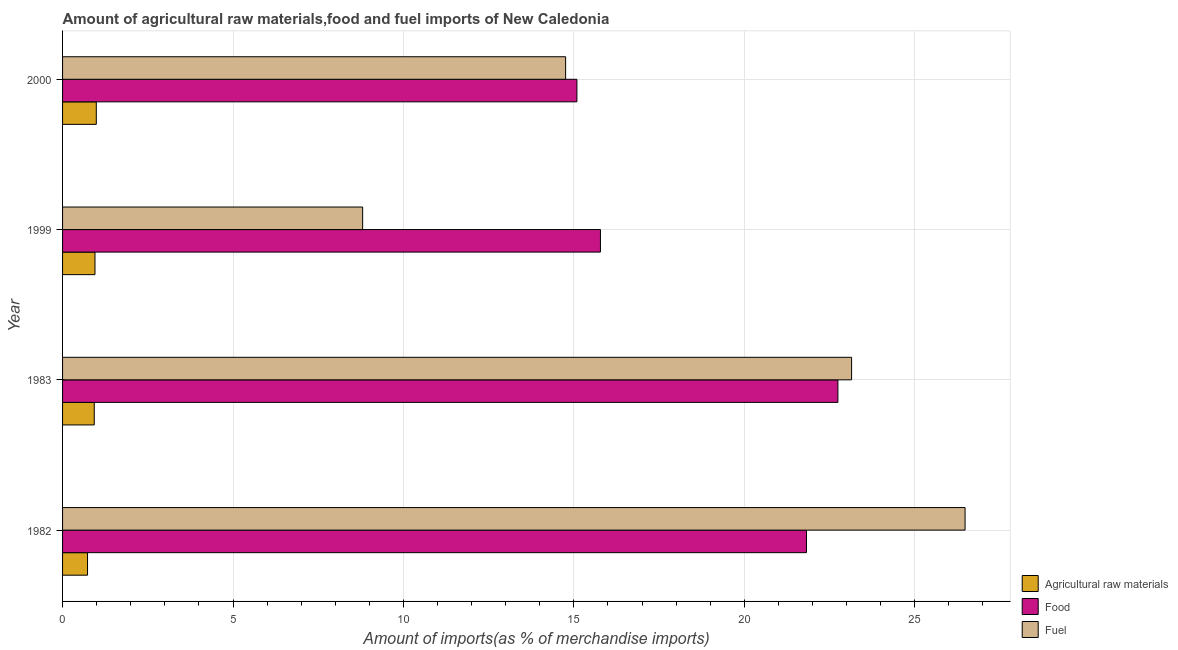How many bars are there on the 1st tick from the bottom?
Keep it short and to the point. 3. What is the label of the 2nd group of bars from the top?
Give a very brief answer. 1999. In how many cases, is the number of bars for a given year not equal to the number of legend labels?
Your answer should be very brief. 0. What is the percentage of food imports in 1983?
Your answer should be compact. 22.75. Across all years, what is the maximum percentage of fuel imports?
Your answer should be very brief. 26.48. Across all years, what is the minimum percentage of fuel imports?
Provide a short and direct response. 8.8. In which year was the percentage of raw materials imports maximum?
Offer a terse response. 2000. In which year was the percentage of fuel imports minimum?
Ensure brevity in your answer.  1999. What is the total percentage of fuel imports in the graph?
Give a very brief answer. 73.19. What is the difference between the percentage of raw materials imports in 1983 and that in 2000?
Provide a succinct answer. -0.06. What is the difference between the percentage of food imports in 1983 and the percentage of raw materials imports in 2000?
Your response must be concise. 21.76. What is the average percentage of raw materials imports per year?
Provide a succinct answer. 0.9. In the year 1999, what is the difference between the percentage of food imports and percentage of fuel imports?
Make the answer very short. 6.98. In how many years, is the percentage of raw materials imports greater than 6 %?
Give a very brief answer. 0. What is the ratio of the percentage of raw materials imports in 1983 to that in 2000?
Offer a very short reply. 0.94. Is the percentage of food imports in 1982 less than that in 1983?
Provide a short and direct response. Yes. What is the difference between the highest and the second highest percentage of raw materials imports?
Your response must be concise. 0.04. What is the difference between the highest and the lowest percentage of raw materials imports?
Your answer should be compact. 0.26. In how many years, is the percentage of food imports greater than the average percentage of food imports taken over all years?
Provide a succinct answer. 2. Is the sum of the percentage of fuel imports in 1982 and 1999 greater than the maximum percentage of raw materials imports across all years?
Give a very brief answer. Yes. What does the 2nd bar from the top in 2000 represents?
Ensure brevity in your answer.  Food. What does the 1st bar from the bottom in 2000 represents?
Your answer should be very brief. Agricultural raw materials. Is it the case that in every year, the sum of the percentage of raw materials imports and percentage of food imports is greater than the percentage of fuel imports?
Offer a terse response. No. How many bars are there?
Provide a short and direct response. 12. How many years are there in the graph?
Offer a terse response. 4. What is the difference between two consecutive major ticks on the X-axis?
Your response must be concise. 5. Are the values on the major ticks of X-axis written in scientific E-notation?
Provide a succinct answer. No. What is the title of the graph?
Provide a short and direct response. Amount of agricultural raw materials,food and fuel imports of New Caledonia. What is the label or title of the X-axis?
Make the answer very short. Amount of imports(as % of merchandise imports). What is the label or title of the Y-axis?
Give a very brief answer. Year. What is the Amount of imports(as % of merchandise imports) in Agricultural raw materials in 1982?
Your answer should be very brief. 0.73. What is the Amount of imports(as % of merchandise imports) in Food in 1982?
Your response must be concise. 21.82. What is the Amount of imports(as % of merchandise imports) in Fuel in 1982?
Provide a short and direct response. 26.48. What is the Amount of imports(as % of merchandise imports) of Agricultural raw materials in 1983?
Provide a short and direct response. 0.93. What is the Amount of imports(as % of merchandise imports) in Food in 1983?
Keep it short and to the point. 22.75. What is the Amount of imports(as % of merchandise imports) in Fuel in 1983?
Keep it short and to the point. 23.15. What is the Amount of imports(as % of merchandise imports) of Agricultural raw materials in 1999?
Ensure brevity in your answer.  0.95. What is the Amount of imports(as % of merchandise imports) in Food in 1999?
Ensure brevity in your answer.  15.78. What is the Amount of imports(as % of merchandise imports) in Fuel in 1999?
Your response must be concise. 8.8. What is the Amount of imports(as % of merchandise imports) of Agricultural raw materials in 2000?
Offer a very short reply. 0.99. What is the Amount of imports(as % of merchandise imports) in Food in 2000?
Make the answer very short. 15.09. What is the Amount of imports(as % of merchandise imports) in Fuel in 2000?
Provide a short and direct response. 14.76. Across all years, what is the maximum Amount of imports(as % of merchandise imports) of Agricultural raw materials?
Your answer should be very brief. 0.99. Across all years, what is the maximum Amount of imports(as % of merchandise imports) in Food?
Ensure brevity in your answer.  22.75. Across all years, what is the maximum Amount of imports(as % of merchandise imports) in Fuel?
Make the answer very short. 26.48. Across all years, what is the minimum Amount of imports(as % of merchandise imports) of Agricultural raw materials?
Provide a short and direct response. 0.73. Across all years, what is the minimum Amount of imports(as % of merchandise imports) of Food?
Your response must be concise. 15.09. Across all years, what is the minimum Amount of imports(as % of merchandise imports) of Fuel?
Provide a short and direct response. 8.8. What is the total Amount of imports(as % of merchandise imports) of Agricultural raw materials in the graph?
Provide a short and direct response. 3.6. What is the total Amount of imports(as % of merchandise imports) in Food in the graph?
Ensure brevity in your answer.  75.44. What is the total Amount of imports(as % of merchandise imports) of Fuel in the graph?
Your response must be concise. 73.19. What is the difference between the Amount of imports(as % of merchandise imports) of Agricultural raw materials in 1982 and that in 1983?
Ensure brevity in your answer.  -0.2. What is the difference between the Amount of imports(as % of merchandise imports) in Food in 1982 and that in 1983?
Give a very brief answer. -0.92. What is the difference between the Amount of imports(as % of merchandise imports) in Fuel in 1982 and that in 1983?
Offer a terse response. 3.33. What is the difference between the Amount of imports(as % of merchandise imports) in Agricultural raw materials in 1982 and that in 1999?
Ensure brevity in your answer.  -0.22. What is the difference between the Amount of imports(as % of merchandise imports) of Food in 1982 and that in 1999?
Offer a very short reply. 6.04. What is the difference between the Amount of imports(as % of merchandise imports) of Fuel in 1982 and that in 1999?
Your response must be concise. 17.67. What is the difference between the Amount of imports(as % of merchandise imports) in Agricultural raw materials in 1982 and that in 2000?
Offer a very short reply. -0.26. What is the difference between the Amount of imports(as % of merchandise imports) in Food in 1982 and that in 2000?
Your answer should be compact. 6.73. What is the difference between the Amount of imports(as % of merchandise imports) in Fuel in 1982 and that in 2000?
Give a very brief answer. 11.72. What is the difference between the Amount of imports(as % of merchandise imports) of Agricultural raw materials in 1983 and that in 1999?
Your answer should be very brief. -0.02. What is the difference between the Amount of imports(as % of merchandise imports) of Food in 1983 and that in 1999?
Your answer should be very brief. 6.97. What is the difference between the Amount of imports(as % of merchandise imports) in Fuel in 1983 and that in 1999?
Give a very brief answer. 14.34. What is the difference between the Amount of imports(as % of merchandise imports) of Agricultural raw materials in 1983 and that in 2000?
Ensure brevity in your answer.  -0.06. What is the difference between the Amount of imports(as % of merchandise imports) in Food in 1983 and that in 2000?
Give a very brief answer. 7.66. What is the difference between the Amount of imports(as % of merchandise imports) in Fuel in 1983 and that in 2000?
Ensure brevity in your answer.  8.39. What is the difference between the Amount of imports(as % of merchandise imports) of Agricultural raw materials in 1999 and that in 2000?
Make the answer very short. -0.04. What is the difference between the Amount of imports(as % of merchandise imports) of Food in 1999 and that in 2000?
Keep it short and to the point. 0.69. What is the difference between the Amount of imports(as % of merchandise imports) in Fuel in 1999 and that in 2000?
Your answer should be compact. -5.95. What is the difference between the Amount of imports(as % of merchandise imports) in Agricultural raw materials in 1982 and the Amount of imports(as % of merchandise imports) in Food in 1983?
Your answer should be very brief. -22.01. What is the difference between the Amount of imports(as % of merchandise imports) of Agricultural raw materials in 1982 and the Amount of imports(as % of merchandise imports) of Fuel in 1983?
Offer a terse response. -22.42. What is the difference between the Amount of imports(as % of merchandise imports) of Food in 1982 and the Amount of imports(as % of merchandise imports) of Fuel in 1983?
Your response must be concise. -1.32. What is the difference between the Amount of imports(as % of merchandise imports) in Agricultural raw materials in 1982 and the Amount of imports(as % of merchandise imports) in Food in 1999?
Your response must be concise. -15.05. What is the difference between the Amount of imports(as % of merchandise imports) in Agricultural raw materials in 1982 and the Amount of imports(as % of merchandise imports) in Fuel in 1999?
Make the answer very short. -8.07. What is the difference between the Amount of imports(as % of merchandise imports) of Food in 1982 and the Amount of imports(as % of merchandise imports) of Fuel in 1999?
Provide a short and direct response. 13.02. What is the difference between the Amount of imports(as % of merchandise imports) of Agricultural raw materials in 1982 and the Amount of imports(as % of merchandise imports) of Food in 2000?
Ensure brevity in your answer.  -14.36. What is the difference between the Amount of imports(as % of merchandise imports) in Agricultural raw materials in 1982 and the Amount of imports(as % of merchandise imports) in Fuel in 2000?
Offer a terse response. -14.03. What is the difference between the Amount of imports(as % of merchandise imports) of Food in 1982 and the Amount of imports(as % of merchandise imports) of Fuel in 2000?
Give a very brief answer. 7.07. What is the difference between the Amount of imports(as % of merchandise imports) of Agricultural raw materials in 1983 and the Amount of imports(as % of merchandise imports) of Food in 1999?
Your answer should be compact. -14.85. What is the difference between the Amount of imports(as % of merchandise imports) in Agricultural raw materials in 1983 and the Amount of imports(as % of merchandise imports) in Fuel in 1999?
Provide a succinct answer. -7.87. What is the difference between the Amount of imports(as % of merchandise imports) in Food in 1983 and the Amount of imports(as % of merchandise imports) in Fuel in 1999?
Give a very brief answer. 13.94. What is the difference between the Amount of imports(as % of merchandise imports) in Agricultural raw materials in 1983 and the Amount of imports(as % of merchandise imports) in Food in 2000?
Ensure brevity in your answer.  -14.16. What is the difference between the Amount of imports(as % of merchandise imports) of Agricultural raw materials in 1983 and the Amount of imports(as % of merchandise imports) of Fuel in 2000?
Your response must be concise. -13.83. What is the difference between the Amount of imports(as % of merchandise imports) of Food in 1983 and the Amount of imports(as % of merchandise imports) of Fuel in 2000?
Your response must be concise. 7.99. What is the difference between the Amount of imports(as % of merchandise imports) in Agricultural raw materials in 1999 and the Amount of imports(as % of merchandise imports) in Food in 2000?
Make the answer very short. -14.14. What is the difference between the Amount of imports(as % of merchandise imports) in Agricultural raw materials in 1999 and the Amount of imports(as % of merchandise imports) in Fuel in 2000?
Make the answer very short. -13.81. What is the difference between the Amount of imports(as % of merchandise imports) in Food in 1999 and the Amount of imports(as % of merchandise imports) in Fuel in 2000?
Offer a very short reply. 1.02. What is the average Amount of imports(as % of merchandise imports) of Agricultural raw materials per year?
Your answer should be compact. 0.9. What is the average Amount of imports(as % of merchandise imports) in Food per year?
Make the answer very short. 18.86. What is the average Amount of imports(as % of merchandise imports) of Fuel per year?
Offer a very short reply. 18.3. In the year 1982, what is the difference between the Amount of imports(as % of merchandise imports) in Agricultural raw materials and Amount of imports(as % of merchandise imports) in Food?
Make the answer very short. -21.09. In the year 1982, what is the difference between the Amount of imports(as % of merchandise imports) of Agricultural raw materials and Amount of imports(as % of merchandise imports) of Fuel?
Give a very brief answer. -25.74. In the year 1982, what is the difference between the Amount of imports(as % of merchandise imports) in Food and Amount of imports(as % of merchandise imports) in Fuel?
Provide a short and direct response. -4.65. In the year 1983, what is the difference between the Amount of imports(as % of merchandise imports) of Agricultural raw materials and Amount of imports(as % of merchandise imports) of Food?
Keep it short and to the point. -21.82. In the year 1983, what is the difference between the Amount of imports(as % of merchandise imports) in Agricultural raw materials and Amount of imports(as % of merchandise imports) in Fuel?
Your answer should be very brief. -22.22. In the year 1983, what is the difference between the Amount of imports(as % of merchandise imports) of Food and Amount of imports(as % of merchandise imports) of Fuel?
Give a very brief answer. -0.4. In the year 1999, what is the difference between the Amount of imports(as % of merchandise imports) in Agricultural raw materials and Amount of imports(as % of merchandise imports) in Food?
Provide a succinct answer. -14.83. In the year 1999, what is the difference between the Amount of imports(as % of merchandise imports) of Agricultural raw materials and Amount of imports(as % of merchandise imports) of Fuel?
Give a very brief answer. -7.85. In the year 1999, what is the difference between the Amount of imports(as % of merchandise imports) of Food and Amount of imports(as % of merchandise imports) of Fuel?
Give a very brief answer. 6.98. In the year 2000, what is the difference between the Amount of imports(as % of merchandise imports) in Agricultural raw materials and Amount of imports(as % of merchandise imports) in Food?
Make the answer very short. -14.1. In the year 2000, what is the difference between the Amount of imports(as % of merchandise imports) in Agricultural raw materials and Amount of imports(as % of merchandise imports) in Fuel?
Your answer should be compact. -13.77. In the year 2000, what is the difference between the Amount of imports(as % of merchandise imports) of Food and Amount of imports(as % of merchandise imports) of Fuel?
Make the answer very short. 0.33. What is the ratio of the Amount of imports(as % of merchandise imports) in Agricultural raw materials in 1982 to that in 1983?
Your answer should be very brief. 0.79. What is the ratio of the Amount of imports(as % of merchandise imports) in Food in 1982 to that in 1983?
Ensure brevity in your answer.  0.96. What is the ratio of the Amount of imports(as % of merchandise imports) of Fuel in 1982 to that in 1983?
Give a very brief answer. 1.14. What is the ratio of the Amount of imports(as % of merchandise imports) in Agricultural raw materials in 1982 to that in 1999?
Your response must be concise. 0.77. What is the ratio of the Amount of imports(as % of merchandise imports) in Food in 1982 to that in 1999?
Your response must be concise. 1.38. What is the ratio of the Amount of imports(as % of merchandise imports) of Fuel in 1982 to that in 1999?
Provide a short and direct response. 3.01. What is the ratio of the Amount of imports(as % of merchandise imports) of Agricultural raw materials in 1982 to that in 2000?
Ensure brevity in your answer.  0.74. What is the ratio of the Amount of imports(as % of merchandise imports) of Food in 1982 to that in 2000?
Offer a terse response. 1.45. What is the ratio of the Amount of imports(as % of merchandise imports) of Fuel in 1982 to that in 2000?
Make the answer very short. 1.79. What is the ratio of the Amount of imports(as % of merchandise imports) in Agricultural raw materials in 1983 to that in 1999?
Make the answer very short. 0.98. What is the ratio of the Amount of imports(as % of merchandise imports) in Food in 1983 to that in 1999?
Provide a succinct answer. 1.44. What is the ratio of the Amount of imports(as % of merchandise imports) of Fuel in 1983 to that in 1999?
Offer a very short reply. 2.63. What is the ratio of the Amount of imports(as % of merchandise imports) in Agricultural raw materials in 1983 to that in 2000?
Your response must be concise. 0.94. What is the ratio of the Amount of imports(as % of merchandise imports) in Food in 1983 to that in 2000?
Offer a very short reply. 1.51. What is the ratio of the Amount of imports(as % of merchandise imports) of Fuel in 1983 to that in 2000?
Make the answer very short. 1.57. What is the ratio of the Amount of imports(as % of merchandise imports) of Agricultural raw materials in 1999 to that in 2000?
Keep it short and to the point. 0.96. What is the ratio of the Amount of imports(as % of merchandise imports) in Food in 1999 to that in 2000?
Give a very brief answer. 1.05. What is the ratio of the Amount of imports(as % of merchandise imports) in Fuel in 1999 to that in 2000?
Your response must be concise. 0.6. What is the difference between the highest and the second highest Amount of imports(as % of merchandise imports) of Agricultural raw materials?
Provide a succinct answer. 0.04. What is the difference between the highest and the second highest Amount of imports(as % of merchandise imports) in Food?
Ensure brevity in your answer.  0.92. What is the difference between the highest and the second highest Amount of imports(as % of merchandise imports) in Fuel?
Keep it short and to the point. 3.33. What is the difference between the highest and the lowest Amount of imports(as % of merchandise imports) of Agricultural raw materials?
Offer a very short reply. 0.26. What is the difference between the highest and the lowest Amount of imports(as % of merchandise imports) in Food?
Your answer should be compact. 7.66. What is the difference between the highest and the lowest Amount of imports(as % of merchandise imports) in Fuel?
Provide a succinct answer. 17.67. 